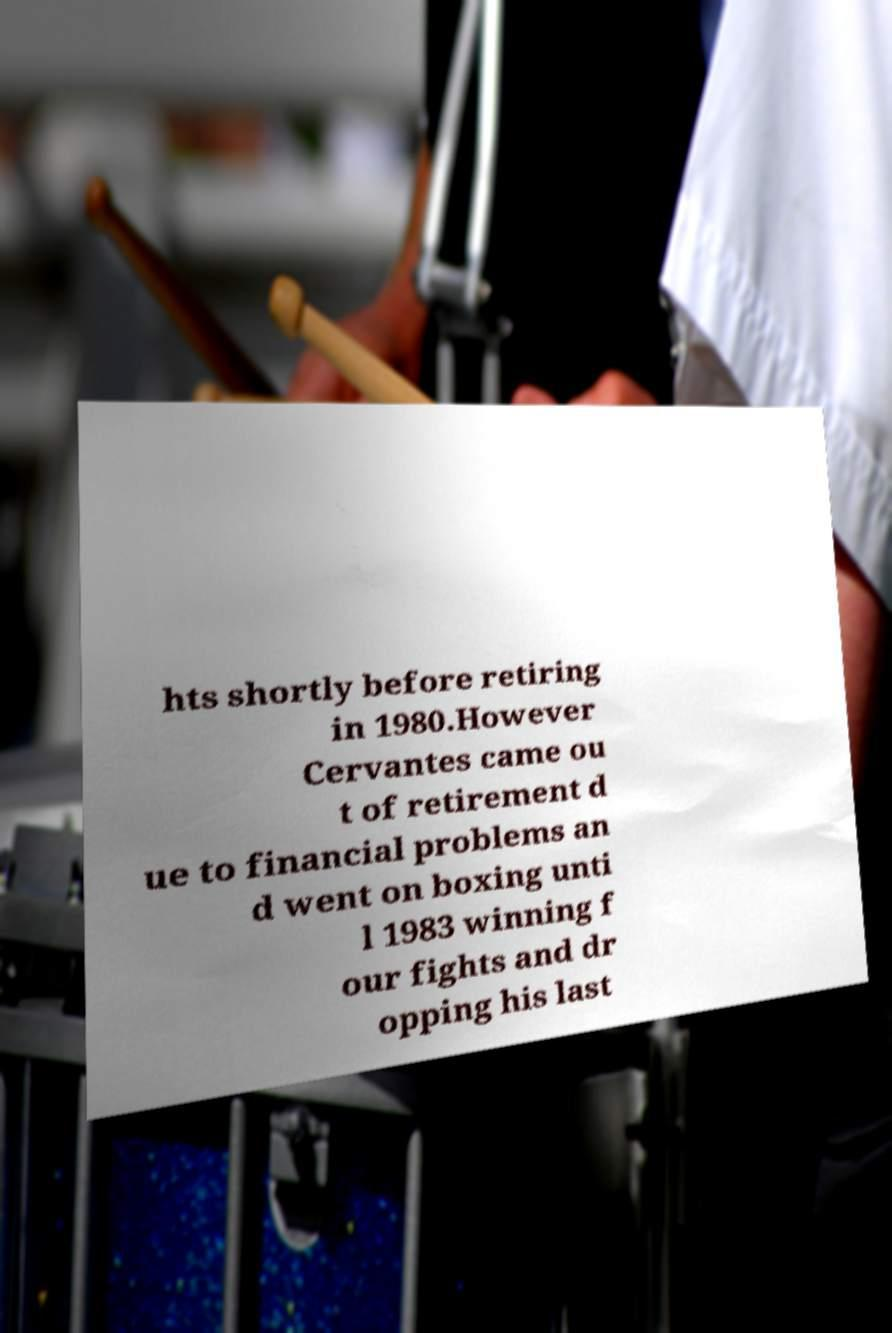For documentation purposes, I need the text within this image transcribed. Could you provide that? hts shortly before retiring in 1980.However Cervantes came ou t of retirement d ue to financial problems an d went on boxing unti l 1983 winning f our fights and dr opping his last 